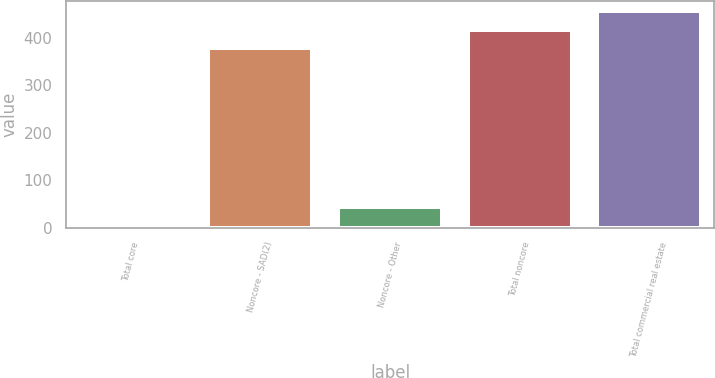Convert chart. <chart><loc_0><loc_0><loc_500><loc_500><bar_chart><fcel>Total core<fcel>Noncore - SAD(2)<fcel>Noncore - Other<fcel>Total noncore<fcel>Total commercial real estate<nl><fcel>5<fcel>379<fcel>43.4<fcel>417.4<fcel>455.8<nl></chart> 